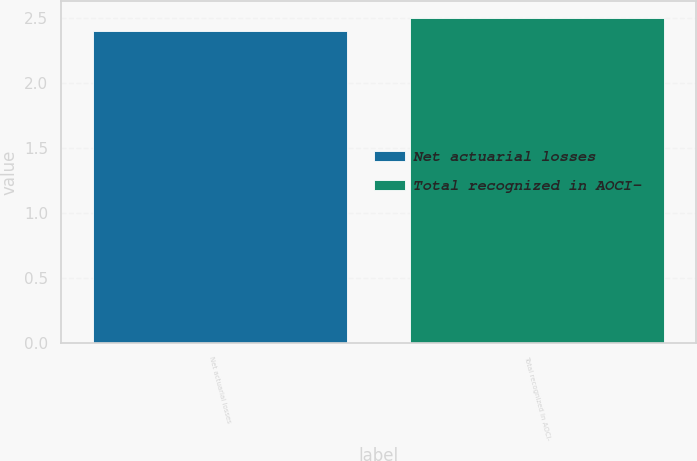<chart> <loc_0><loc_0><loc_500><loc_500><bar_chart><fcel>Net actuarial losses<fcel>Total recognized in AOCI-<nl><fcel>2.4<fcel>2.5<nl></chart> 